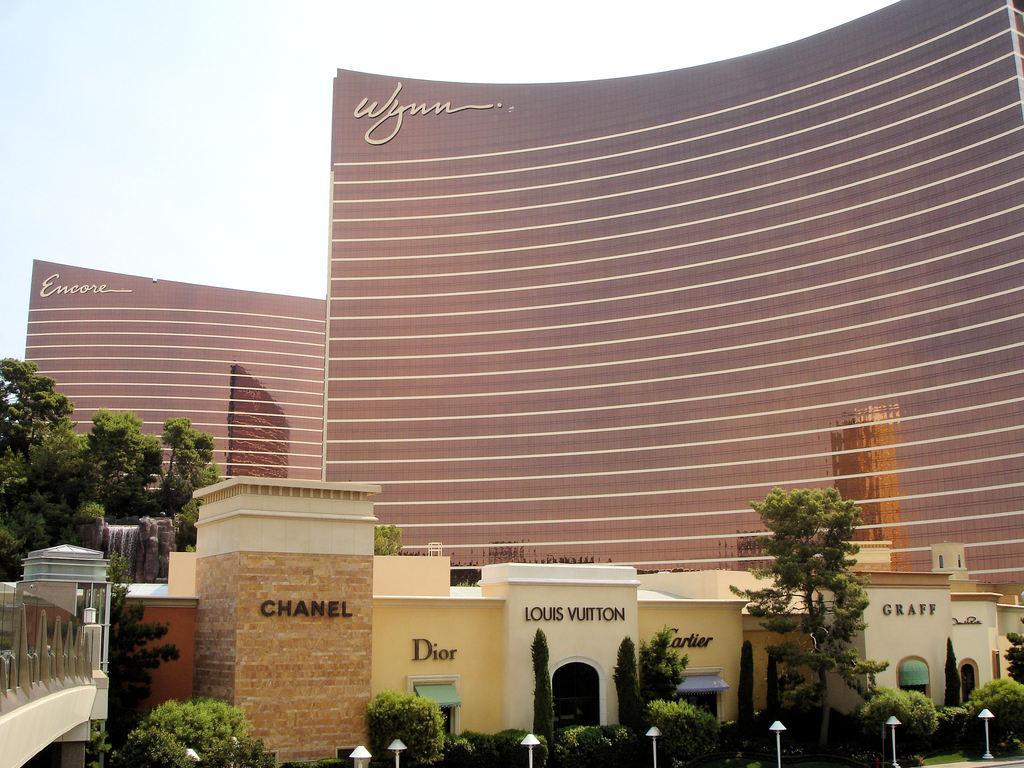Could you give a brief overview of what you see in this image? In this picture there are plants at the bottom side of the image and there are building blocks in the center of the image, there are huge buildings in the background area of the image and there are trees on the left side of the image. 